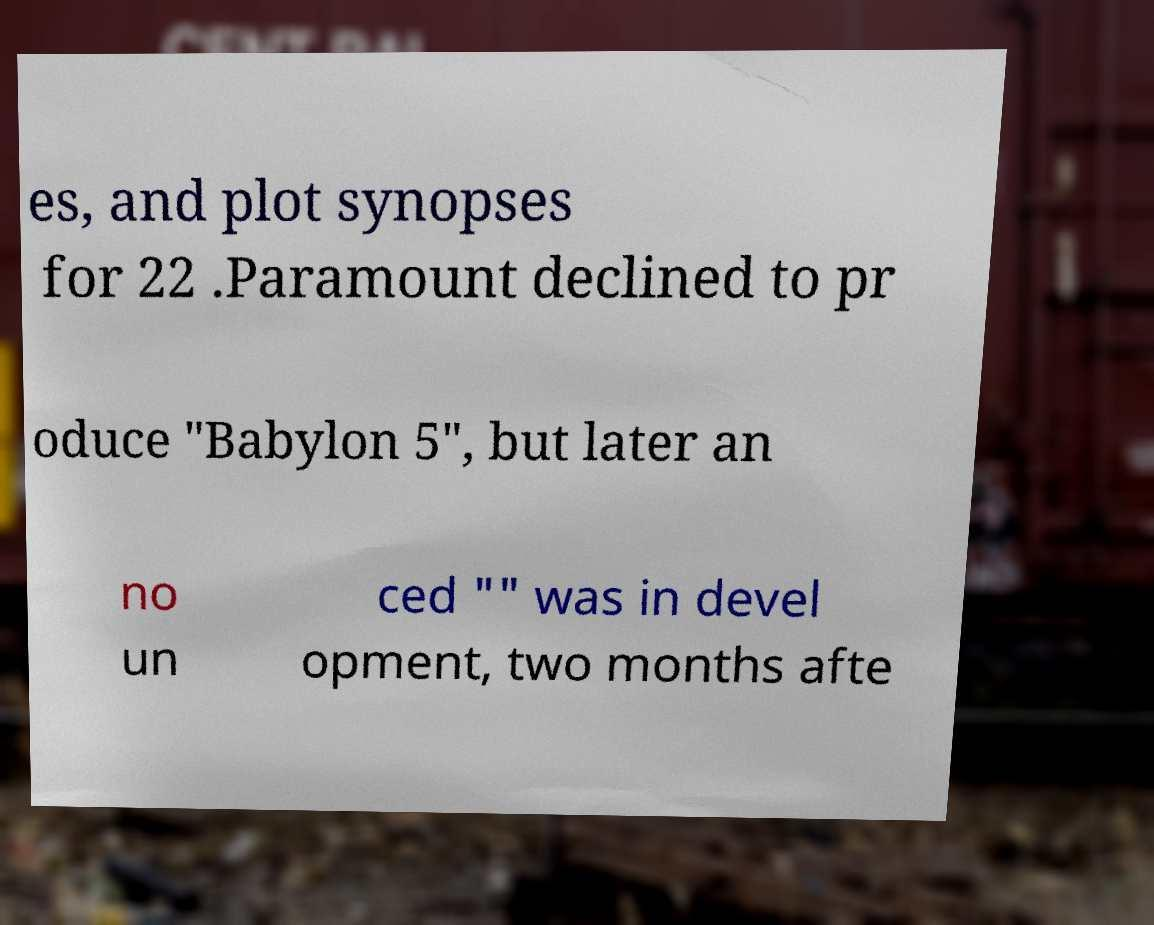Please read and relay the text visible in this image. What does it say? es, and plot synopses for 22 .Paramount declined to pr oduce "Babylon 5", but later an no un ced "" was in devel opment, two months afte 